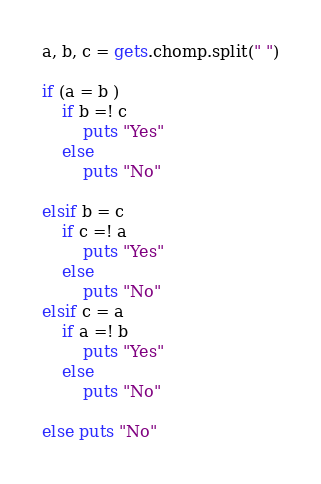Convert code to text. <code><loc_0><loc_0><loc_500><loc_500><_Ruby_>a, b, c = gets.chomp.split(" ")

if (a = b )
    if b =! c
        puts "Yes"
    else
        puts "No"

elsif b = c
    if c =! a
        puts "Yes"
    else
        puts "No"
elsif c = a
    if a =! b
        puts "Yes"
    else
        puts "No"

else puts "No"

</code> 